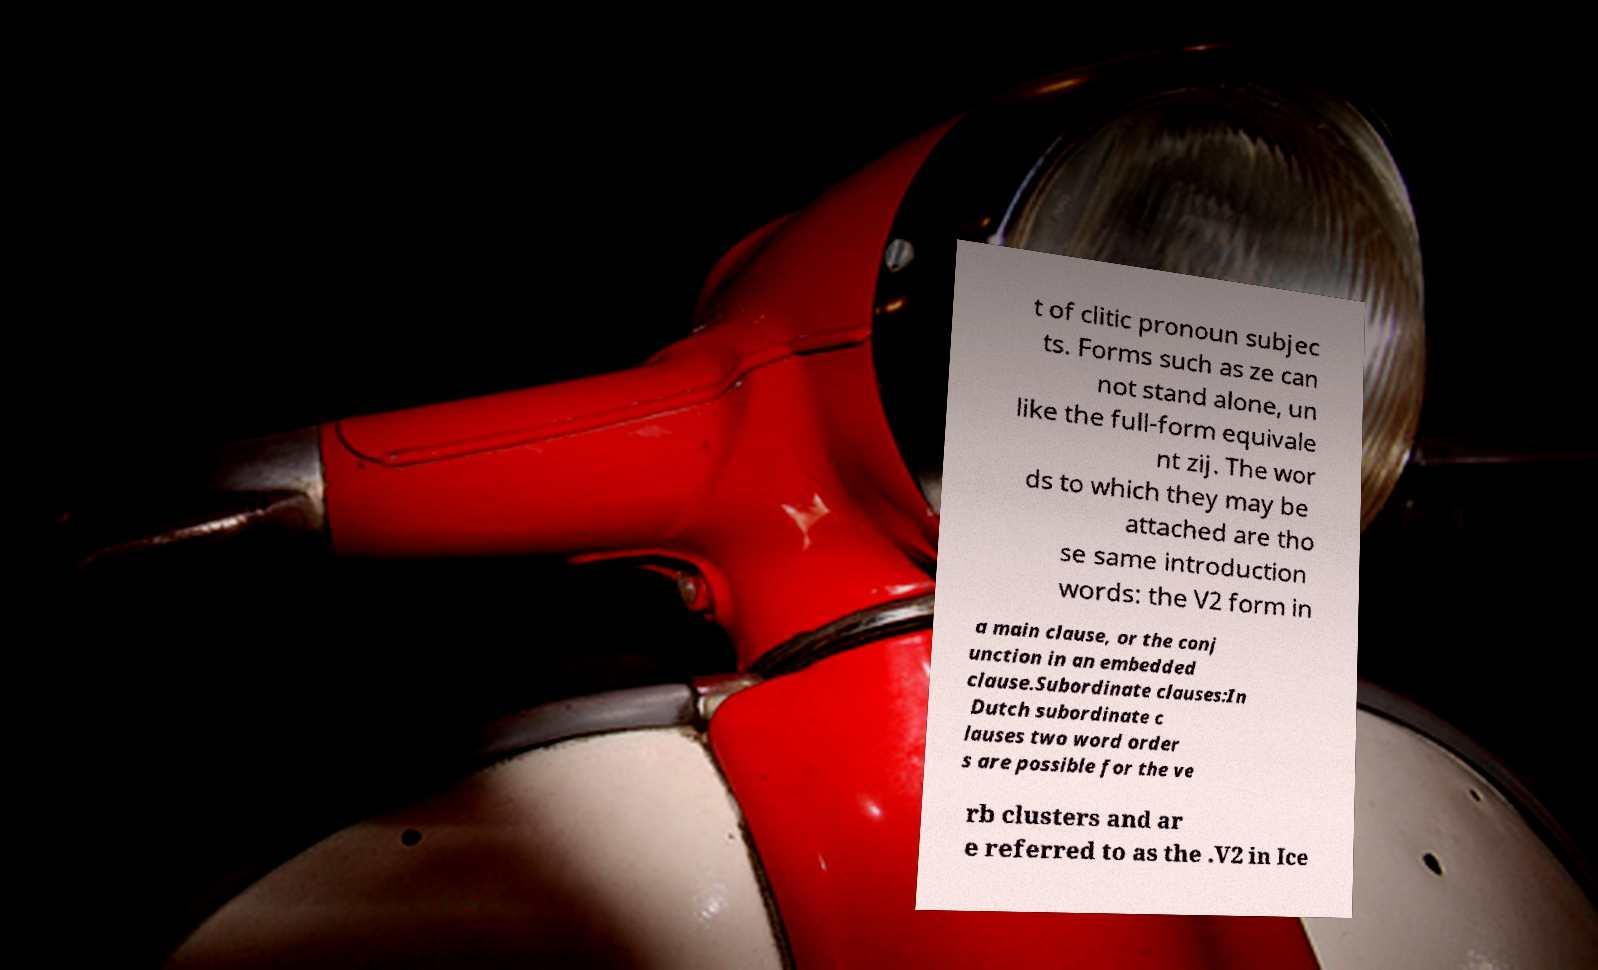Could you extract and type out the text from this image? t of clitic pronoun subjec ts. Forms such as ze can not stand alone, un like the full-form equivale nt zij. The wor ds to which they may be attached are tho se same introduction words: the V2 form in a main clause, or the conj unction in an embedded clause.Subordinate clauses:In Dutch subordinate c lauses two word order s are possible for the ve rb clusters and ar e referred to as the .V2 in Ice 